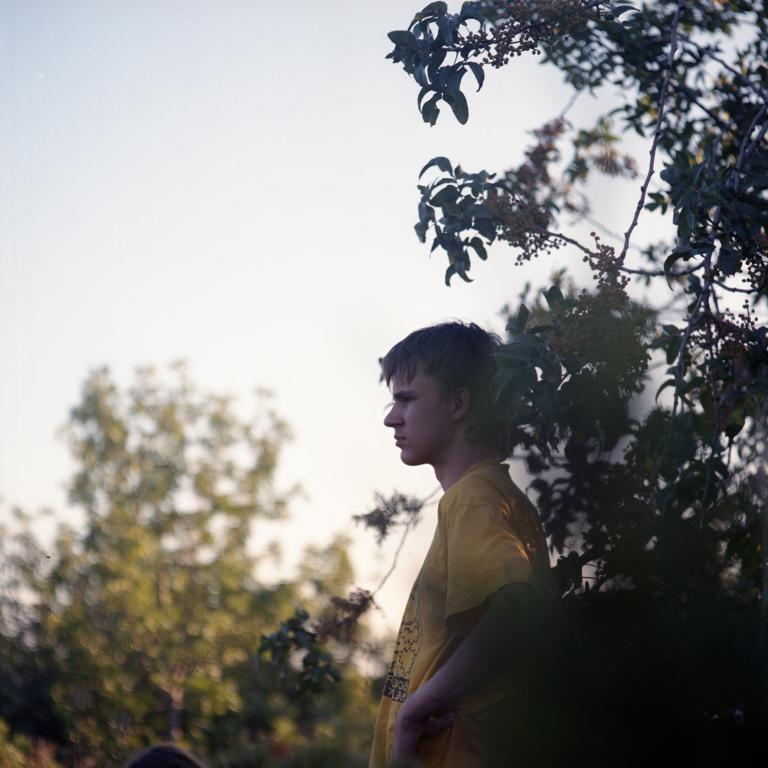Who is present in the image? There is a man in the image. What is the man wearing? The man is wearing a yellow t-shirt. What type of natural environment can be seen in the image? There are trees visible in the image. What is visible in the background of the image? The sky is present in the image. What type of record is the man holding in the image? There is no record present in the image; the man is not holding anything. 